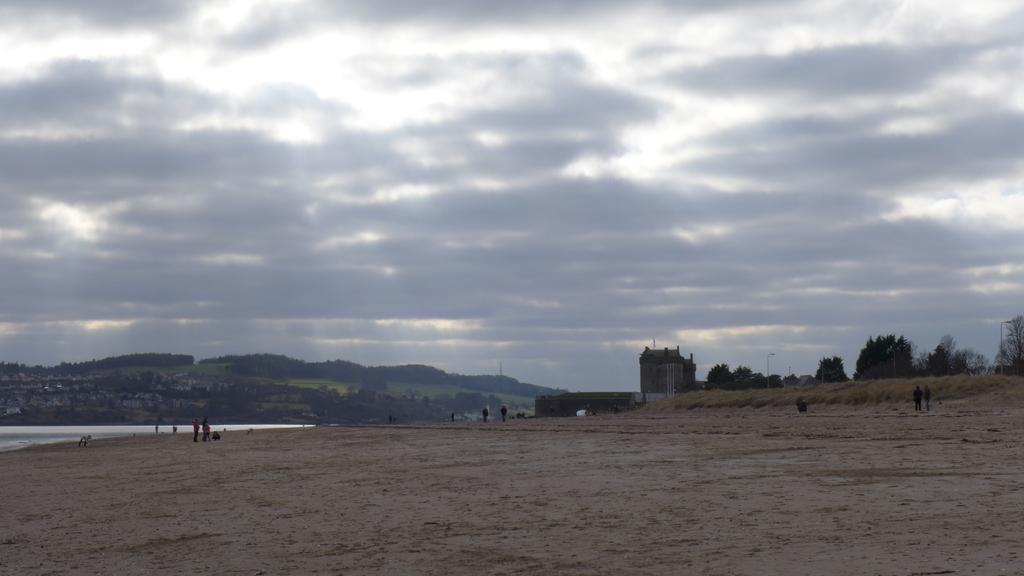How many people are in the image? There is a group of people in the image, but the exact number is not specified. What type of structure can be seen in the image? There is a building in the image. What other natural elements are present in the image? There are trees, hills, and water visible in the image. What is the background of the image? The sky is visible in the background of the image. What man-made objects can be seen in the image? There are poles in the image. Can you see a lawyer wearing a crown in the image? There is no lawyer or crown present in the image. What type of truck is visible in the image? There is no truck present in the image. 